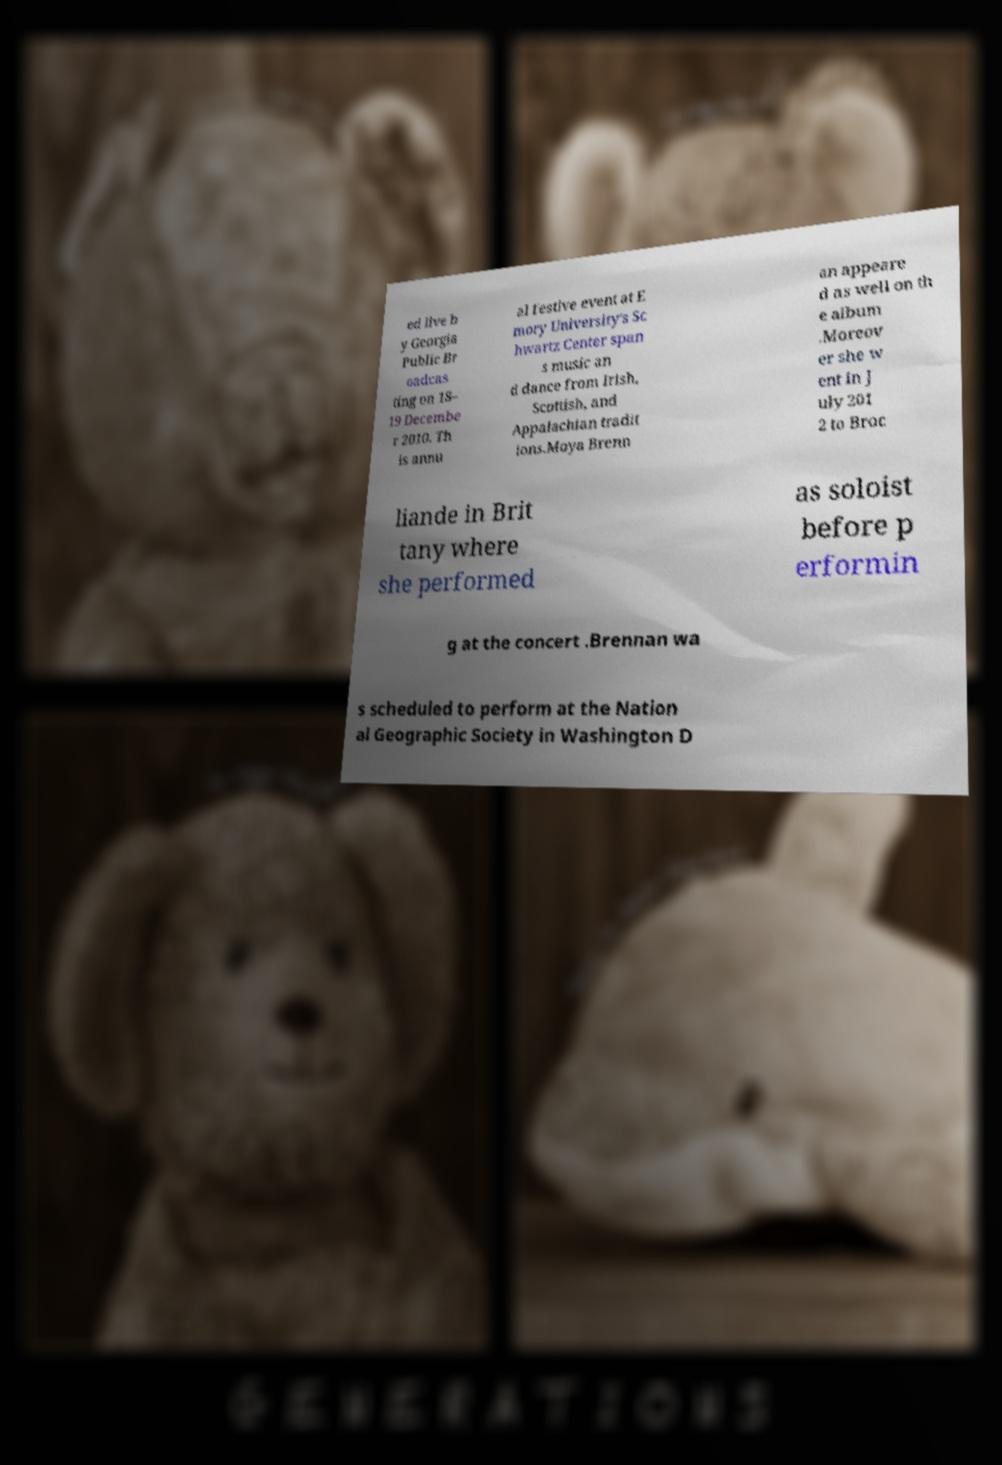Please read and relay the text visible in this image. What does it say? ed live b y Georgia Public Br oadcas ting on 18– 19 Decembe r 2010. Th is annu al festive event at E mory University's Sc hwartz Center span s music an d dance from Irish, Scottish, and Appalachian tradit ions.Moya Brenn an appeare d as well on th e album .Moreov er she w ent in J uly 201 2 to Broc liande in Brit tany where she performed as soloist before p erformin g at the concert .Brennan wa s scheduled to perform at the Nation al Geographic Society in Washington D 